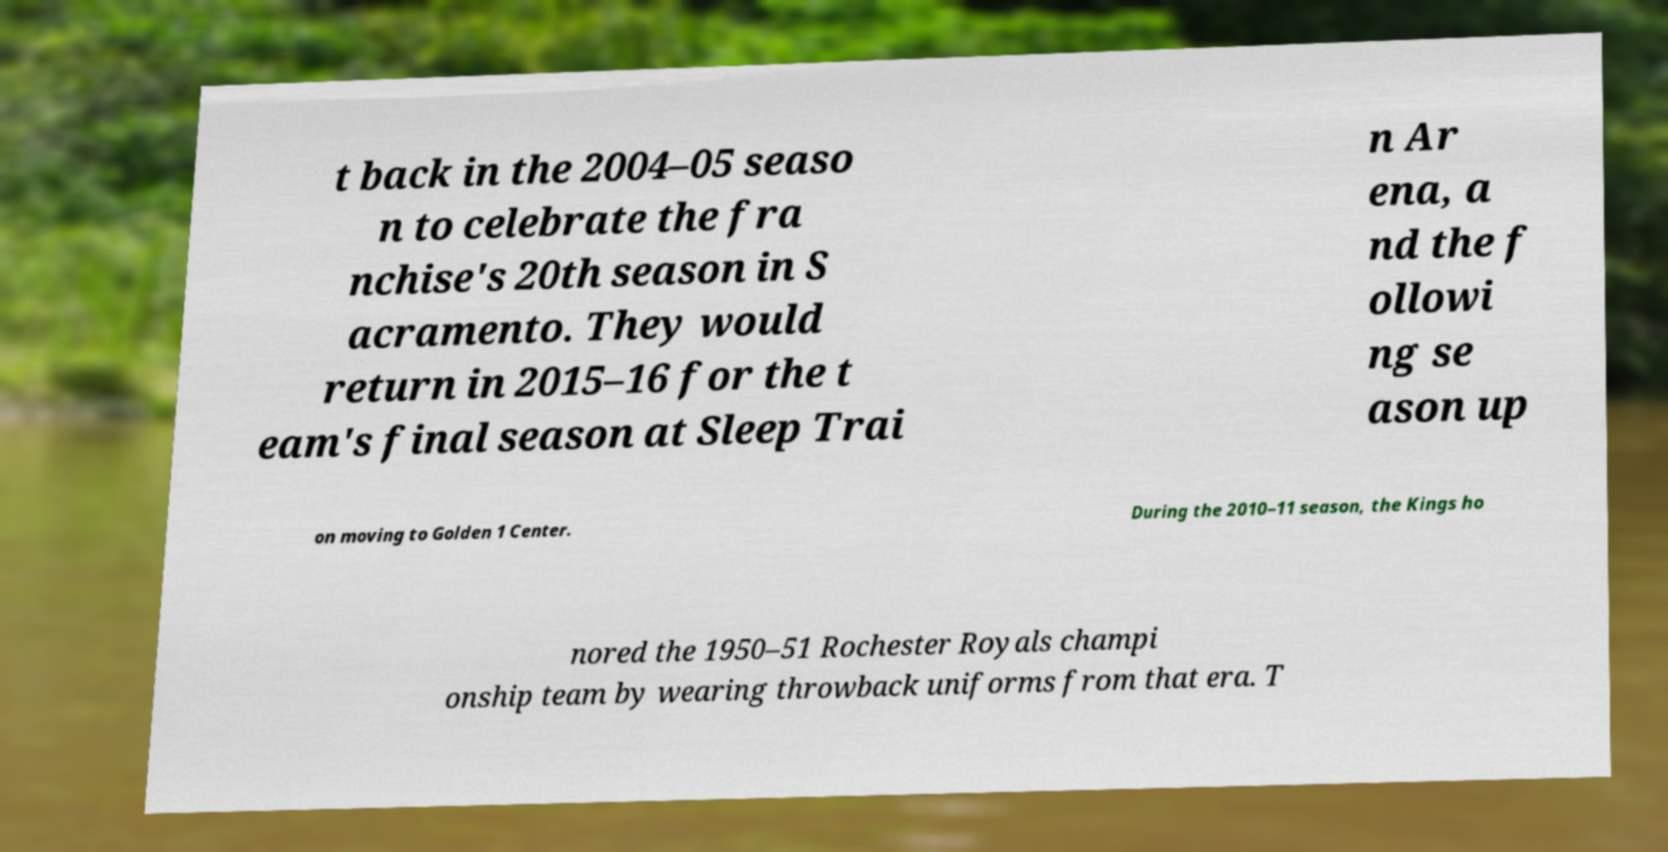Could you assist in decoding the text presented in this image and type it out clearly? t back in the 2004–05 seaso n to celebrate the fra nchise's 20th season in S acramento. They would return in 2015–16 for the t eam's final season at Sleep Trai n Ar ena, a nd the f ollowi ng se ason up on moving to Golden 1 Center. During the 2010–11 season, the Kings ho nored the 1950–51 Rochester Royals champi onship team by wearing throwback uniforms from that era. T 